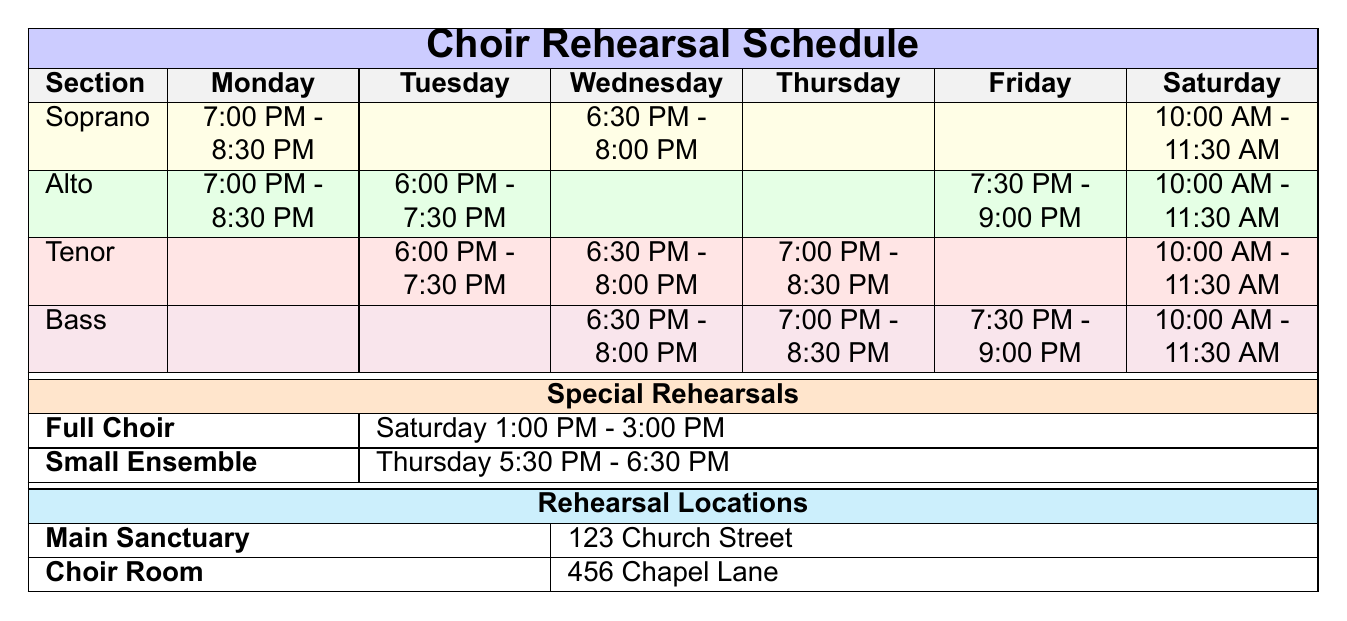What time does the Soprano section rehearse on Wednesday? The table indicates that the Soprano section rehearses on Wednesday from 6:30 PM to 8:00 PM.
Answer: 6:30 PM - 8:00 PM How many sections rehearse on Saturday? By checking the table, it shows that all four sections (Soprano, Alto, Tenor, and Bass) rehearse on Saturday at the same time of 10:00 AM - 11:30 AM.
Answer: 4 Is there a rehearsal for the Tenor section on Monday? The table shows that there is no rehearsal scheduled for the Tenor section on Monday, as that cell is left blank.
Answer: No Which section has a rehearsal on Thursday? The table shows that the Tenor and Bass sections have rehearsals on Thursday (7:00 PM - 8:30 PM for both).
Answer: Tenor, Bass How do the durations of Saturday rehearsals for each section compare? Each section rehearses for 1.5 hours on Saturday from 10:00 AM to 11:30 AM, leading to the conclusion that all sections have the same duration for that day.
Answer: They are the same What is the total duration of rehearsals for the Alto section over the week? The Alto section has rehearsals on Monday (1.5 hours), Tuesday (1.5 hours), Friday (1.5 hours), and Saturday (1.5 hours). Summing these gives 1.5 + 1.5 + 1.5 + 1.5 = 6 hours total.
Answer: 6 hours Do any sections have overlapping rehearsal times on Tuesday? The Tenor and Alto sections both rehearse on Tuesday from 6:00 PM to 7:30 PM. This indicates that they overlap completely during this time.
Answer: Yes What are the locations for the rehearsal sessions? The table lists two locations: Main Sanctuary at 123 Church Street and Choir Room at 456 Chapel Lane, indicating where the rehearsals occur.
Answer: Main Sanctuary, Choir Room On which days does the Full Choir have special rehearsals? The Full Choir has a special rehearsal on Saturday from 1:00 PM to 3:00 PM, as shown in the special rehearsals section of the table.
Answer: Saturday How many total hours is scheduled for special rehearsals? The Full Choir rehearsal is 2 hours and the Small Ensemble rehearsal is 1 hour, totaling 2 + 1 = 3 hours scheduled for special rehearsals.
Answer: 3 hours 